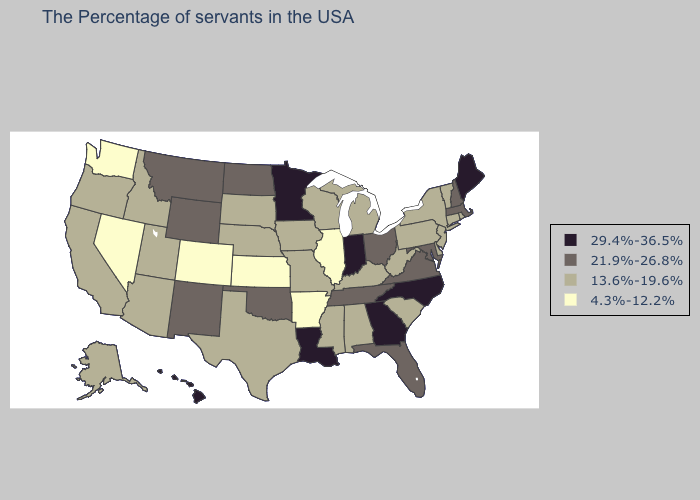Does Wyoming have the same value as Alaska?
Concise answer only. No. Name the states that have a value in the range 29.4%-36.5%?
Short answer required. Maine, North Carolina, Georgia, Indiana, Louisiana, Minnesota, Hawaii. Is the legend a continuous bar?
Quick response, please. No. Among the states that border Florida , which have the highest value?
Concise answer only. Georgia. Among the states that border Texas , does Oklahoma have the highest value?
Short answer required. No. Name the states that have a value in the range 29.4%-36.5%?
Give a very brief answer. Maine, North Carolina, Georgia, Indiana, Louisiana, Minnesota, Hawaii. What is the value of Missouri?
Answer briefly. 13.6%-19.6%. Among the states that border Kentucky , does West Virginia have the lowest value?
Be succinct. No. What is the lowest value in the USA?
Write a very short answer. 4.3%-12.2%. Does Arkansas have the lowest value in the South?
Keep it brief. Yes. Name the states that have a value in the range 29.4%-36.5%?
Concise answer only. Maine, North Carolina, Georgia, Indiana, Louisiana, Minnesota, Hawaii. Does the map have missing data?
Short answer required. No. Is the legend a continuous bar?
Keep it brief. No. Name the states that have a value in the range 13.6%-19.6%?
Be succinct. Rhode Island, Vermont, Connecticut, New York, New Jersey, Delaware, Pennsylvania, South Carolina, West Virginia, Michigan, Kentucky, Alabama, Wisconsin, Mississippi, Missouri, Iowa, Nebraska, Texas, South Dakota, Utah, Arizona, Idaho, California, Oregon, Alaska. Does Georgia have the highest value in the South?
Give a very brief answer. Yes. 